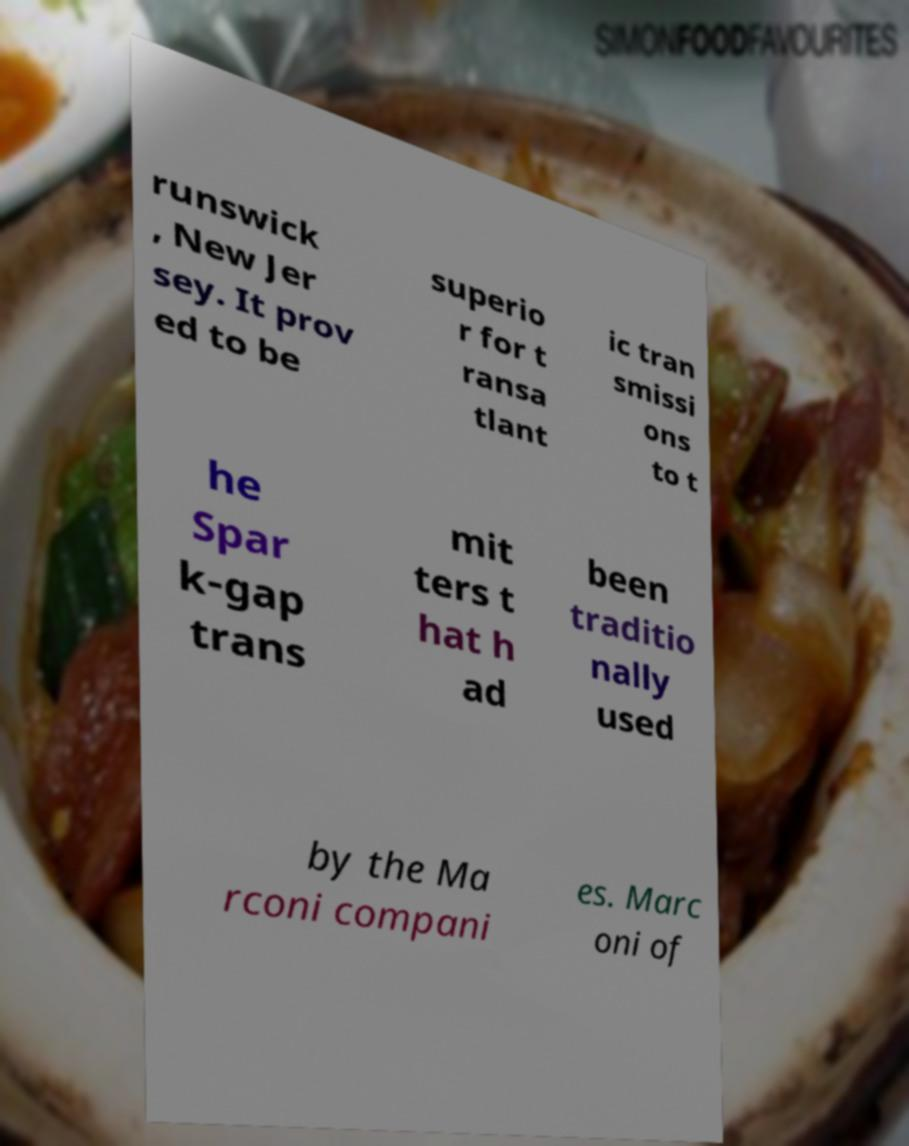Please read and relay the text visible in this image. What does it say? runswick , New Jer sey. It prov ed to be superio r for t ransa tlant ic tran smissi ons to t he Spar k-gap trans mit ters t hat h ad been traditio nally used by the Ma rconi compani es. Marc oni of 